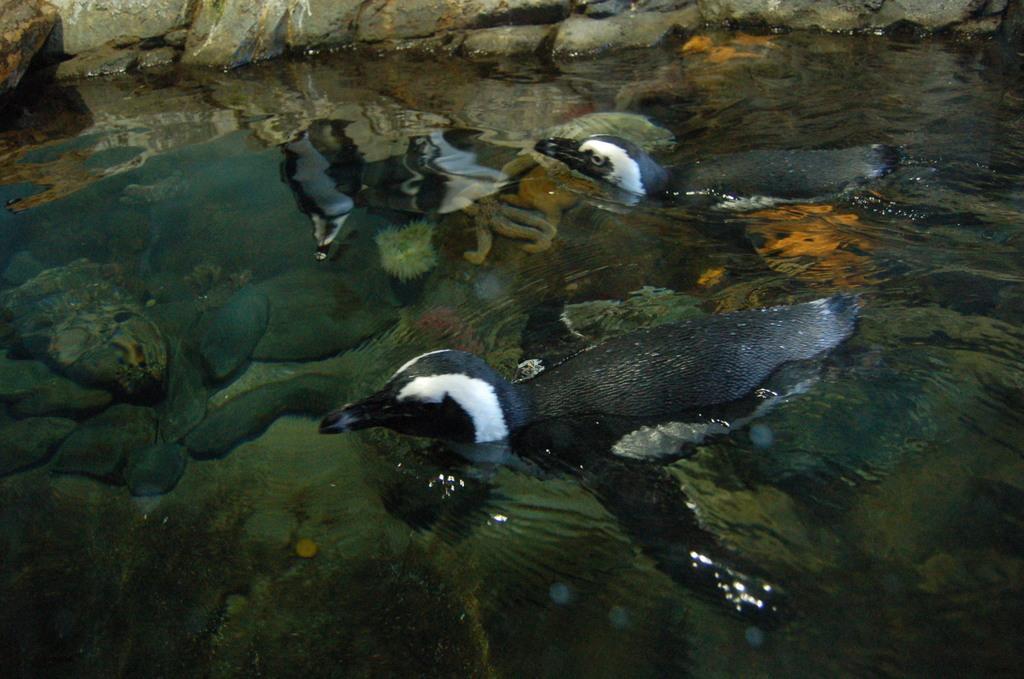Can you describe this image briefly? In this picture we can see birds in the water and we can see few rocks. 